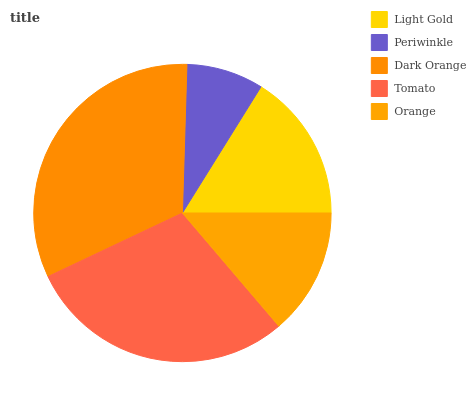Is Periwinkle the minimum?
Answer yes or no. Yes. Is Dark Orange the maximum?
Answer yes or no. Yes. Is Dark Orange the minimum?
Answer yes or no. No. Is Periwinkle the maximum?
Answer yes or no. No. Is Dark Orange greater than Periwinkle?
Answer yes or no. Yes. Is Periwinkle less than Dark Orange?
Answer yes or no. Yes. Is Periwinkle greater than Dark Orange?
Answer yes or no. No. Is Dark Orange less than Periwinkle?
Answer yes or no. No. Is Light Gold the high median?
Answer yes or no. Yes. Is Light Gold the low median?
Answer yes or no. Yes. Is Periwinkle the high median?
Answer yes or no. No. Is Orange the low median?
Answer yes or no. No. 